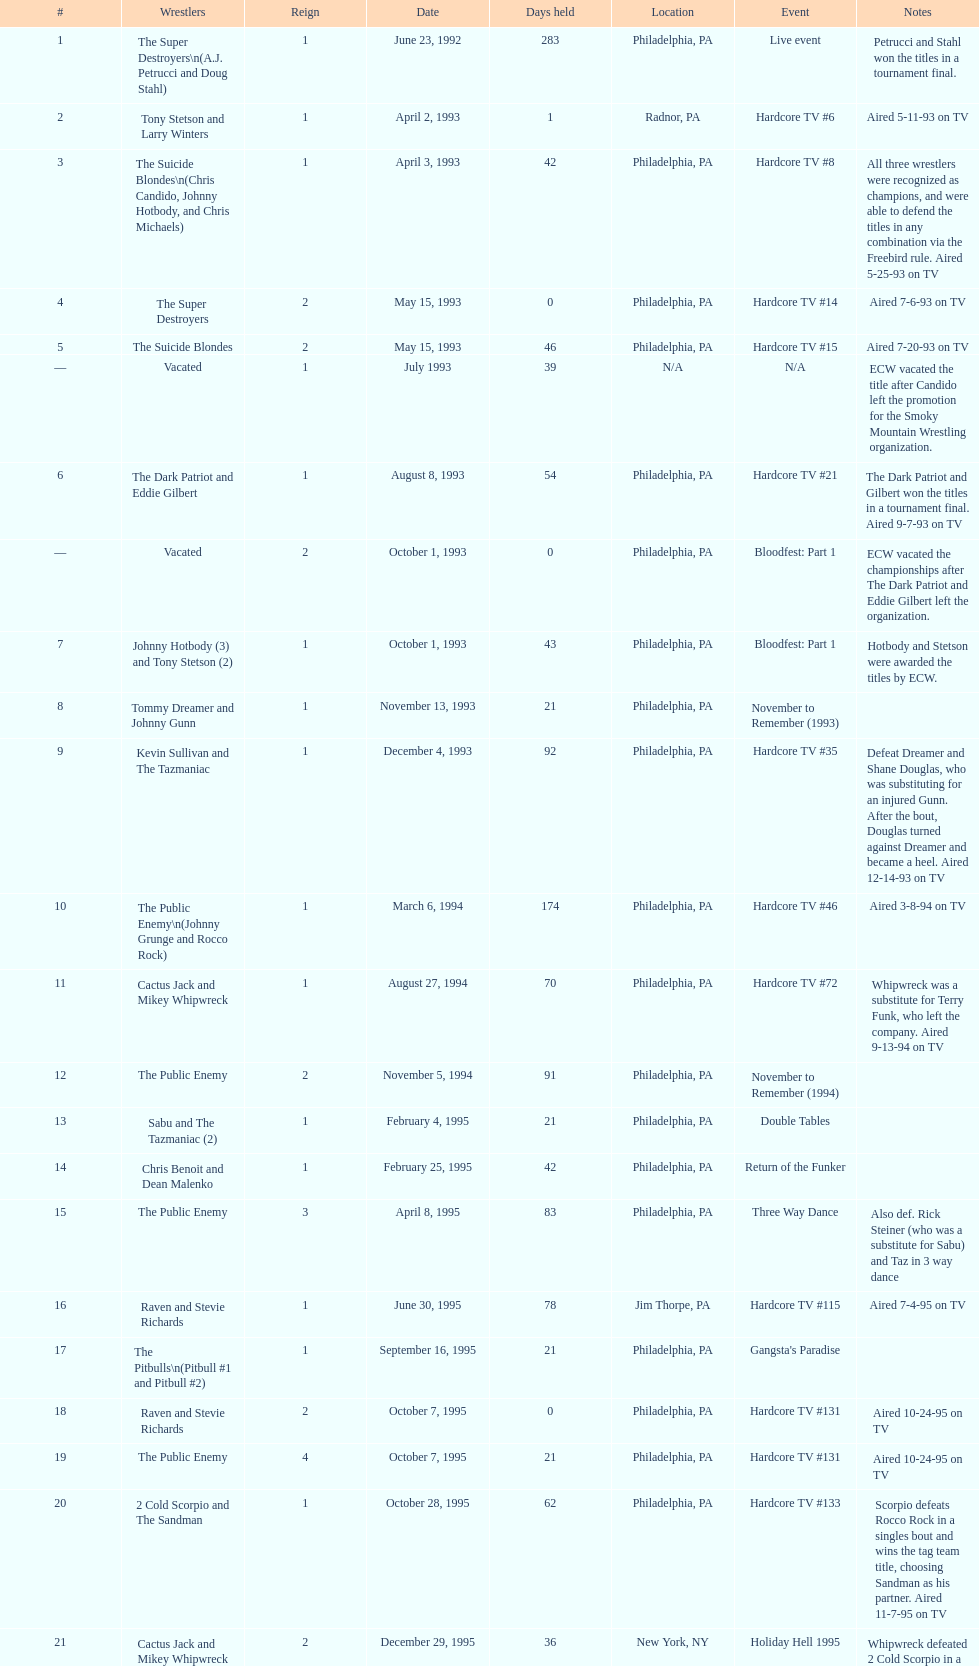Help me parse the entirety of this table. {'header': ['#', 'Wrestlers', 'Reign', 'Date', 'Days held', 'Location', 'Event', 'Notes'], 'rows': [['1', 'The Super Destroyers\\n(A.J. Petrucci and Doug Stahl)', '1', 'June 23, 1992', '283', 'Philadelphia, PA', 'Live event', 'Petrucci and Stahl won the titles in a tournament final.'], ['2', 'Tony Stetson and Larry Winters', '1', 'April 2, 1993', '1', 'Radnor, PA', 'Hardcore TV #6', 'Aired 5-11-93 on TV'], ['3', 'The Suicide Blondes\\n(Chris Candido, Johnny Hotbody, and Chris Michaels)', '1', 'April 3, 1993', '42', 'Philadelphia, PA', 'Hardcore TV #8', 'All three wrestlers were recognized as champions, and were able to defend the titles in any combination via the Freebird rule. Aired 5-25-93 on TV'], ['4', 'The Super Destroyers', '2', 'May 15, 1993', '0', 'Philadelphia, PA', 'Hardcore TV #14', 'Aired 7-6-93 on TV'], ['5', 'The Suicide Blondes', '2', 'May 15, 1993', '46', 'Philadelphia, PA', 'Hardcore TV #15', 'Aired 7-20-93 on TV'], ['—', 'Vacated', '1', 'July 1993', '39', 'N/A', 'N/A', 'ECW vacated the title after Candido left the promotion for the Smoky Mountain Wrestling organization.'], ['6', 'The Dark Patriot and Eddie Gilbert', '1', 'August 8, 1993', '54', 'Philadelphia, PA', 'Hardcore TV #21', 'The Dark Patriot and Gilbert won the titles in a tournament final. Aired 9-7-93 on TV'], ['—', 'Vacated', '2', 'October 1, 1993', '0', 'Philadelphia, PA', 'Bloodfest: Part 1', 'ECW vacated the championships after The Dark Patriot and Eddie Gilbert left the organization.'], ['7', 'Johnny Hotbody (3) and Tony Stetson (2)', '1', 'October 1, 1993', '43', 'Philadelphia, PA', 'Bloodfest: Part 1', 'Hotbody and Stetson were awarded the titles by ECW.'], ['8', 'Tommy Dreamer and Johnny Gunn', '1', 'November 13, 1993', '21', 'Philadelphia, PA', 'November to Remember (1993)', ''], ['9', 'Kevin Sullivan and The Tazmaniac', '1', 'December 4, 1993', '92', 'Philadelphia, PA', 'Hardcore TV #35', 'Defeat Dreamer and Shane Douglas, who was substituting for an injured Gunn. After the bout, Douglas turned against Dreamer and became a heel. Aired 12-14-93 on TV'], ['10', 'The Public Enemy\\n(Johnny Grunge and Rocco Rock)', '1', 'March 6, 1994', '174', 'Philadelphia, PA', 'Hardcore TV #46', 'Aired 3-8-94 on TV'], ['11', 'Cactus Jack and Mikey Whipwreck', '1', 'August 27, 1994', '70', 'Philadelphia, PA', 'Hardcore TV #72', 'Whipwreck was a substitute for Terry Funk, who left the company. Aired 9-13-94 on TV'], ['12', 'The Public Enemy', '2', 'November 5, 1994', '91', 'Philadelphia, PA', 'November to Remember (1994)', ''], ['13', 'Sabu and The Tazmaniac (2)', '1', 'February 4, 1995', '21', 'Philadelphia, PA', 'Double Tables', ''], ['14', 'Chris Benoit and Dean Malenko', '1', 'February 25, 1995', '42', 'Philadelphia, PA', 'Return of the Funker', ''], ['15', 'The Public Enemy', '3', 'April 8, 1995', '83', 'Philadelphia, PA', 'Three Way Dance', 'Also def. Rick Steiner (who was a substitute for Sabu) and Taz in 3 way dance'], ['16', 'Raven and Stevie Richards', '1', 'June 30, 1995', '78', 'Jim Thorpe, PA', 'Hardcore TV #115', 'Aired 7-4-95 on TV'], ['17', 'The Pitbulls\\n(Pitbull #1 and Pitbull #2)', '1', 'September 16, 1995', '21', 'Philadelphia, PA', "Gangsta's Paradise", ''], ['18', 'Raven and Stevie Richards', '2', 'October 7, 1995', '0', 'Philadelphia, PA', 'Hardcore TV #131', 'Aired 10-24-95 on TV'], ['19', 'The Public Enemy', '4', 'October 7, 1995', '21', 'Philadelphia, PA', 'Hardcore TV #131', 'Aired 10-24-95 on TV'], ['20', '2 Cold Scorpio and The Sandman', '1', 'October 28, 1995', '62', 'Philadelphia, PA', 'Hardcore TV #133', 'Scorpio defeats Rocco Rock in a singles bout and wins the tag team title, choosing Sandman as his partner. Aired 11-7-95 on TV'], ['21', 'Cactus Jack and Mikey Whipwreck', '2', 'December 29, 1995', '36', 'New York, NY', 'Holiday Hell 1995', "Whipwreck defeated 2 Cold Scorpio in a singles match to win both the tag team titles and the ECW World Television Championship; Cactus Jack came out and declared himself to be Mikey's partner after he won the match."], ['22', 'The Eliminators\\n(Kronus and Saturn)', '1', 'February 3, 1996', '182', 'New York, NY', 'Big Apple Blizzard Blast', ''], ['23', 'The Gangstas\\n(Mustapha Saed and New Jack)', '1', 'August 3, 1996', '139', 'Philadelphia, PA', 'Doctor Is In', ''], ['24', 'The Eliminators', '2', 'December 20, 1996', '85', 'Middletown, NY', 'Hardcore TV #193', 'Aired on 12/31/96 on Hardcore TV'], ['25', 'The Dudley Boyz\\n(Buh Buh Ray Dudley and D-Von Dudley)', '1', 'March 15, 1997', '29', 'Philadelphia, PA', 'Hostile City Showdown', 'Aired 3/20/97 on Hardcore TV'], ['26', 'The Eliminators', '3', 'April 13, 1997', '68', 'Philadelphia, PA', 'Barely Legal', ''], ['27', 'The Dudley Boyz', '2', 'June 20, 1997', '29', 'Waltham, MA', 'Hardcore TV #218', 'The Dudley Boyz defeated Kronus in a handicap match as a result of a sidelining injury sustained by Saturn. Aired 6-26-97 on TV'], ['28', 'The Gangstas', '2', 'July 19, 1997', '29', 'Philadelphia, PA', 'Heat Wave 1997/Hardcore TV #222', 'Aired 7-24-97 on TV'], ['29', 'The Dudley Boyz', '3', 'August 17, 1997', '95', 'Fort Lauderdale, FL', 'Hardcore Heaven (1997)', 'The Dudley Boyz won the championship via forfeit as a result of Mustapha Saed leaving the promotion before Hardcore Heaven took place.'], ['30', 'The Gangstanators\\n(Kronus (4) and New Jack (3))', '1', 'September 20, 1997', '28', 'Philadelphia, PA', 'As Good as it Gets', 'Aired 9-27-97 on TV'], ['31', 'Full Blooded Italians\\n(Little Guido and Tracy Smothers)', '1', 'October 18, 1997', '48', 'Philadelphia, PA', 'Hardcore TV #236', 'Aired 11-1-97 on TV'], ['32', 'Doug Furnas and Phil LaFon', '1', 'December 5, 1997', '1', 'Waltham, MA', 'Live event', ''], ['33', 'Chris Candido (3) and Lance Storm', '1', 'December 6, 1997', '203', 'Philadelphia, PA', 'Better than Ever', ''], ['34', 'Sabu (2) and Rob Van Dam', '1', 'June 27, 1998', '119', 'Philadelphia, PA', 'Hardcore TV #271', 'Aired 7-1-98 on TV'], ['35', 'The Dudley Boyz', '4', 'October 24, 1998', '8', 'Cleveland, OH', 'Hardcore TV #288', 'Aired 10-28-98 on TV'], ['36', 'Balls Mahoney and Masato Tanaka', '1', 'November 1, 1998', '5', 'New Orleans, LA', 'November to Remember (1998)', ''], ['37', 'The Dudley Boyz', '5', 'November 6, 1998', '37', 'New York, NY', 'Hardcore TV #290', 'Aired 11-11-98 on TV'], ['38', 'Sabu (3) and Rob Van Dam', '2', 'December 13, 1998', '125', 'Tokyo, Japan', 'ECW/FMW Supershow II', 'Aired 12-16-98 on TV'], ['39', 'The Dudley Boyz', '6', 'April 17, 1999', '92', 'Buffalo, NY', 'Hardcore TV #313', 'D-Von Dudley defeated Van Dam in a singles match to win the championship for his team. Aired 4-23-99 on TV'], ['40', 'Spike Dudley and Balls Mahoney (2)', '1', 'July 18, 1999', '26', 'Dayton, OH', 'Heat Wave (1999)', ''], ['41', 'The Dudley Boyz', '7', 'August 13, 1999', '1', 'Cleveland, OH', 'Hardcore TV #330', 'Aired 8-20-99 on TV'], ['42', 'Spike Dudley and Balls Mahoney (3)', '2', 'August 14, 1999', '12', 'Toledo, OH', 'Hardcore TV #331', 'Aired 8-27-99 on TV'], ['43', 'The Dudley Boyz', '8', 'August 26, 1999', '0', 'New York, NY', 'ECW on TNN#2', 'Aired 9-3-99 on TV'], ['44', 'Tommy Dreamer (2) and Raven (3)', '1', 'August 26, 1999', '136', 'New York, NY', 'ECW on TNN#2', 'Aired 9-3-99 on TV'], ['45', 'Impact Players\\n(Justin Credible and Lance Storm (2))', '1', 'January 9, 2000', '48', 'Birmingham, AL', 'Guilty as Charged (2000)', ''], ['46', 'Tommy Dreamer (3) and Masato Tanaka (2)', '1', 'February 26, 2000', '7', 'Cincinnati, OH', 'Hardcore TV #358', 'Aired 3-7-00 on TV'], ['47', 'Mike Awesome and Raven (4)', '1', 'March 4, 2000', '8', 'Philadelphia, PA', 'ECW on TNN#29', 'Aired 3-10-00 on TV'], ['48', 'Impact Players\\n(Justin Credible and Lance Storm (3))', '2', 'March 12, 2000', '31', 'Danbury, CT', 'Living Dangerously', ''], ['—', 'Vacated', '3', 'April 22, 2000', '125', 'Philadelphia, PA', 'Live event', 'At CyberSlam, Justin Credible threw down the titles to become eligible for the ECW World Heavyweight Championship. Storm later left for World Championship Wrestling. As a result of the circumstances, Credible vacated the championship.'], ['49', 'Yoshihiro Tajiri and Mikey Whipwreck (3)', '1', 'August 25, 2000', '1', 'New York, NY', 'ECW on TNN#55', 'Aired 9-1-00 on TV'], ['50', 'Full Blooded Italians\\n(Little Guido (2) and Tony Mamaluke)', '1', 'August 26, 2000', '99', 'New York, NY', 'ECW on TNN#56', 'Aired 9-8-00 on TV'], ['51', 'Danny Doring and Roadkill', '1', 'December 3, 2000', '122', 'New York, NY', 'Massacre on 34th Street', "Doring and Roadkill's reign was the final one in the title's history."]]} What event comes before hardcore tv #14? Hardcore TV #8. 